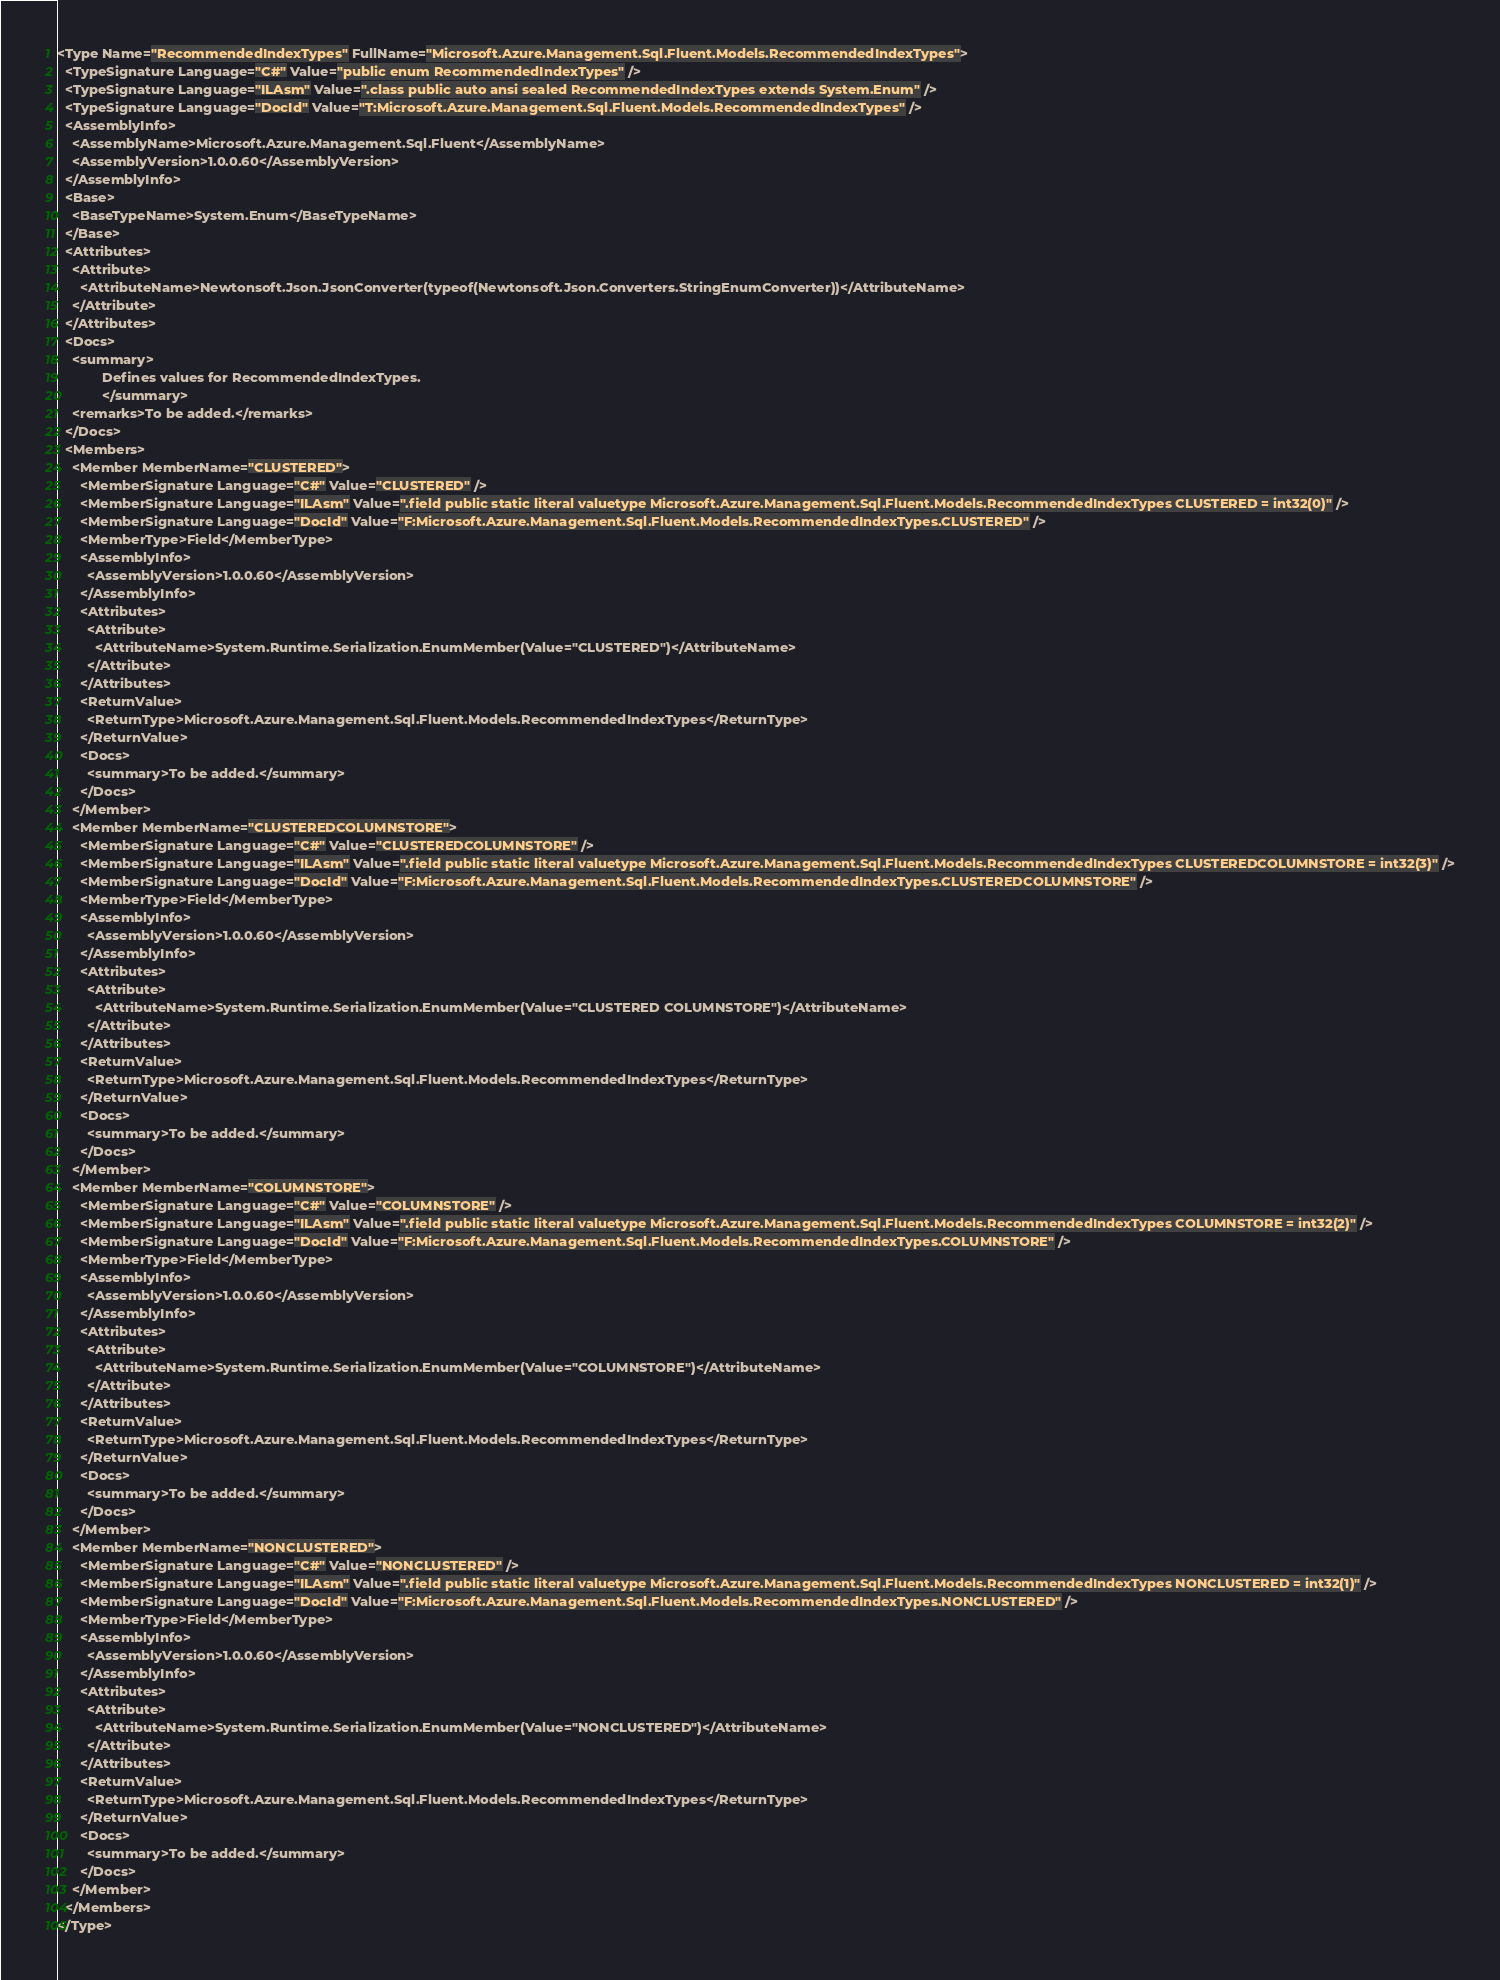Convert code to text. <code><loc_0><loc_0><loc_500><loc_500><_XML_><Type Name="RecommendedIndexTypes" FullName="Microsoft.Azure.Management.Sql.Fluent.Models.RecommendedIndexTypes">
  <TypeSignature Language="C#" Value="public enum RecommendedIndexTypes" />
  <TypeSignature Language="ILAsm" Value=".class public auto ansi sealed RecommendedIndexTypes extends System.Enum" />
  <TypeSignature Language="DocId" Value="T:Microsoft.Azure.Management.Sql.Fluent.Models.RecommendedIndexTypes" />
  <AssemblyInfo>
    <AssemblyName>Microsoft.Azure.Management.Sql.Fluent</AssemblyName>
    <AssemblyVersion>1.0.0.60</AssemblyVersion>
  </AssemblyInfo>
  <Base>
    <BaseTypeName>System.Enum</BaseTypeName>
  </Base>
  <Attributes>
    <Attribute>
      <AttributeName>Newtonsoft.Json.JsonConverter(typeof(Newtonsoft.Json.Converters.StringEnumConverter))</AttributeName>
    </Attribute>
  </Attributes>
  <Docs>
    <summary>
            Defines values for RecommendedIndexTypes.
            </summary>
    <remarks>To be added.</remarks>
  </Docs>
  <Members>
    <Member MemberName="CLUSTERED">
      <MemberSignature Language="C#" Value="CLUSTERED" />
      <MemberSignature Language="ILAsm" Value=".field public static literal valuetype Microsoft.Azure.Management.Sql.Fluent.Models.RecommendedIndexTypes CLUSTERED = int32(0)" />
      <MemberSignature Language="DocId" Value="F:Microsoft.Azure.Management.Sql.Fluent.Models.RecommendedIndexTypes.CLUSTERED" />
      <MemberType>Field</MemberType>
      <AssemblyInfo>
        <AssemblyVersion>1.0.0.60</AssemblyVersion>
      </AssemblyInfo>
      <Attributes>
        <Attribute>
          <AttributeName>System.Runtime.Serialization.EnumMember(Value="CLUSTERED")</AttributeName>
        </Attribute>
      </Attributes>
      <ReturnValue>
        <ReturnType>Microsoft.Azure.Management.Sql.Fluent.Models.RecommendedIndexTypes</ReturnType>
      </ReturnValue>
      <Docs>
        <summary>To be added.</summary>
      </Docs>
    </Member>
    <Member MemberName="CLUSTEREDCOLUMNSTORE">
      <MemberSignature Language="C#" Value="CLUSTEREDCOLUMNSTORE" />
      <MemberSignature Language="ILAsm" Value=".field public static literal valuetype Microsoft.Azure.Management.Sql.Fluent.Models.RecommendedIndexTypes CLUSTEREDCOLUMNSTORE = int32(3)" />
      <MemberSignature Language="DocId" Value="F:Microsoft.Azure.Management.Sql.Fluent.Models.RecommendedIndexTypes.CLUSTEREDCOLUMNSTORE" />
      <MemberType>Field</MemberType>
      <AssemblyInfo>
        <AssemblyVersion>1.0.0.60</AssemblyVersion>
      </AssemblyInfo>
      <Attributes>
        <Attribute>
          <AttributeName>System.Runtime.Serialization.EnumMember(Value="CLUSTERED COLUMNSTORE")</AttributeName>
        </Attribute>
      </Attributes>
      <ReturnValue>
        <ReturnType>Microsoft.Azure.Management.Sql.Fluent.Models.RecommendedIndexTypes</ReturnType>
      </ReturnValue>
      <Docs>
        <summary>To be added.</summary>
      </Docs>
    </Member>
    <Member MemberName="COLUMNSTORE">
      <MemberSignature Language="C#" Value="COLUMNSTORE" />
      <MemberSignature Language="ILAsm" Value=".field public static literal valuetype Microsoft.Azure.Management.Sql.Fluent.Models.RecommendedIndexTypes COLUMNSTORE = int32(2)" />
      <MemberSignature Language="DocId" Value="F:Microsoft.Azure.Management.Sql.Fluent.Models.RecommendedIndexTypes.COLUMNSTORE" />
      <MemberType>Field</MemberType>
      <AssemblyInfo>
        <AssemblyVersion>1.0.0.60</AssemblyVersion>
      </AssemblyInfo>
      <Attributes>
        <Attribute>
          <AttributeName>System.Runtime.Serialization.EnumMember(Value="COLUMNSTORE")</AttributeName>
        </Attribute>
      </Attributes>
      <ReturnValue>
        <ReturnType>Microsoft.Azure.Management.Sql.Fluent.Models.RecommendedIndexTypes</ReturnType>
      </ReturnValue>
      <Docs>
        <summary>To be added.</summary>
      </Docs>
    </Member>
    <Member MemberName="NONCLUSTERED">
      <MemberSignature Language="C#" Value="NONCLUSTERED" />
      <MemberSignature Language="ILAsm" Value=".field public static literal valuetype Microsoft.Azure.Management.Sql.Fluent.Models.RecommendedIndexTypes NONCLUSTERED = int32(1)" />
      <MemberSignature Language="DocId" Value="F:Microsoft.Azure.Management.Sql.Fluent.Models.RecommendedIndexTypes.NONCLUSTERED" />
      <MemberType>Field</MemberType>
      <AssemblyInfo>
        <AssemblyVersion>1.0.0.60</AssemblyVersion>
      </AssemblyInfo>
      <Attributes>
        <Attribute>
          <AttributeName>System.Runtime.Serialization.EnumMember(Value="NONCLUSTERED")</AttributeName>
        </Attribute>
      </Attributes>
      <ReturnValue>
        <ReturnType>Microsoft.Azure.Management.Sql.Fluent.Models.RecommendedIndexTypes</ReturnType>
      </ReturnValue>
      <Docs>
        <summary>To be added.</summary>
      </Docs>
    </Member>
  </Members>
</Type>
</code> 